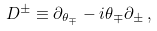Convert formula to latex. <formula><loc_0><loc_0><loc_500><loc_500>D ^ { \pm } \equiv \partial _ { \theta _ { \mp } } - i \theta _ { \mp } \partial _ { \pm } \, ,</formula> 